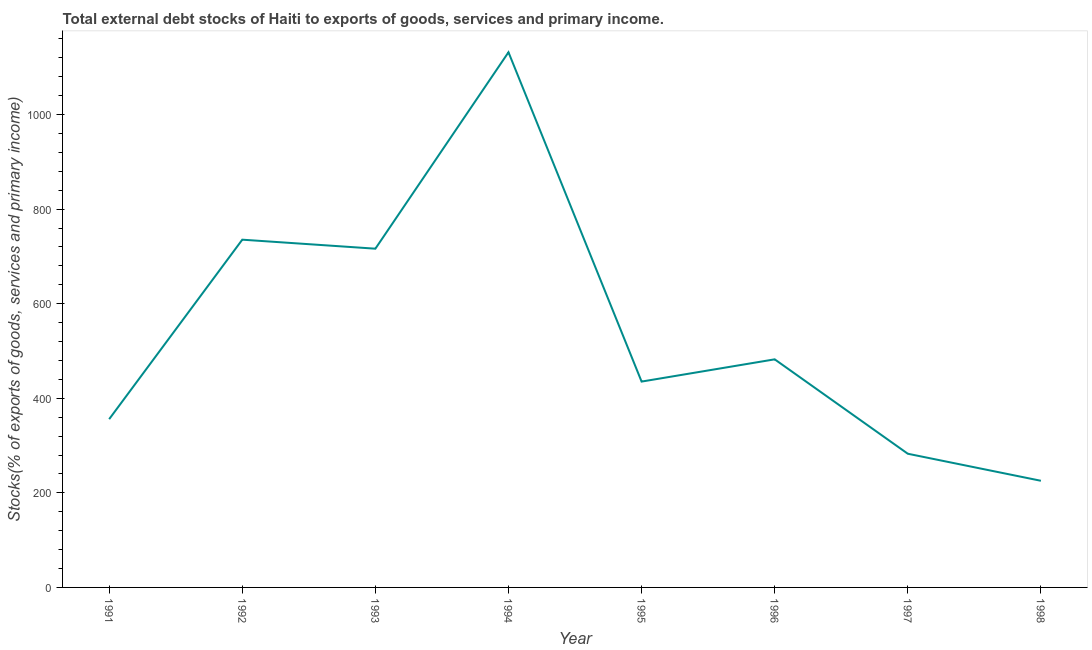What is the external debt stocks in 1995?
Your answer should be compact. 435.33. Across all years, what is the maximum external debt stocks?
Give a very brief answer. 1131.82. Across all years, what is the minimum external debt stocks?
Offer a very short reply. 225.54. In which year was the external debt stocks maximum?
Provide a succinct answer. 1994. What is the sum of the external debt stocks?
Your response must be concise. 4365.47. What is the difference between the external debt stocks in 1995 and 1996?
Ensure brevity in your answer.  -47.05. What is the average external debt stocks per year?
Provide a short and direct response. 545.68. What is the median external debt stocks?
Keep it short and to the point. 458.85. In how many years, is the external debt stocks greater than 360 %?
Provide a short and direct response. 5. Do a majority of the years between 1993 and 1994 (inclusive) have external debt stocks greater than 640 %?
Offer a very short reply. Yes. What is the ratio of the external debt stocks in 1992 to that in 1995?
Your answer should be very brief. 1.69. Is the external debt stocks in 1994 less than that in 1996?
Provide a succinct answer. No. Is the difference between the external debt stocks in 1992 and 1993 greater than the difference between any two years?
Your answer should be compact. No. What is the difference between the highest and the second highest external debt stocks?
Provide a short and direct response. 396.38. Is the sum of the external debt stocks in 1993 and 1995 greater than the maximum external debt stocks across all years?
Your response must be concise. Yes. What is the difference between the highest and the lowest external debt stocks?
Keep it short and to the point. 906.28. How many lines are there?
Keep it short and to the point. 1. How many years are there in the graph?
Your answer should be compact. 8. What is the difference between two consecutive major ticks on the Y-axis?
Give a very brief answer. 200. Are the values on the major ticks of Y-axis written in scientific E-notation?
Provide a short and direct response. No. What is the title of the graph?
Keep it short and to the point. Total external debt stocks of Haiti to exports of goods, services and primary income. What is the label or title of the X-axis?
Provide a short and direct response. Year. What is the label or title of the Y-axis?
Your answer should be very brief. Stocks(% of exports of goods, services and primary income). What is the Stocks(% of exports of goods, services and primary income) of 1991?
Give a very brief answer. 355.87. What is the Stocks(% of exports of goods, services and primary income) of 1992?
Your answer should be compact. 735.43. What is the Stocks(% of exports of goods, services and primary income) in 1993?
Your answer should be compact. 716.38. What is the Stocks(% of exports of goods, services and primary income) in 1994?
Offer a terse response. 1131.82. What is the Stocks(% of exports of goods, services and primary income) of 1995?
Give a very brief answer. 435.33. What is the Stocks(% of exports of goods, services and primary income) in 1996?
Provide a short and direct response. 482.38. What is the Stocks(% of exports of goods, services and primary income) in 1997?
Give a very brief answer. 282.72. What is the Stocks(% of exports of goods, services and primary income) in 1998?
Give a very brief answer. 225.54. What is the difference between the Stocks(% of exports of goods, services and primary income) in 1991 and 1992?
Offer a very short reply. -379.57. What is the difference between the Stocks(% of exports of goods, services and primary income) in 1991 and 1993?
Offer a terse response. -360.51. What is the difference between the Stocks(% of exports of goods, services and primary income) in 1991 and 1994?
Your answer should be compact. -775.95. What is the difference between the Stocks(% of exports of goods, services and primary income) in 1991 and 1995?
Your response must be concise. -79.46. What is the difference between the Stocks(% of exports of goods, services and primary income) in 1991 and 1996?
Make the answer very short. -126.51. What is the difference between the Stocks(% of exports of goods, services and primary income) in 1991 and 1997?
Your response must be concise. 73.15. What is the difference between the Stocks(% of exports of goods, services and primary income) in 1991 and 1998?
Your answer should be compact. 130.33. What is the difference between the Stocks(% of exports of goods, services and primary income) in 1992 and 1993?
Give a very brief answer. 19.05. What is the difference between the Stocks(% of exports of goods, services and primary income) in 1992 and 1994?
Make the answer very short. -396.38. What is the difference between the Stocks(% of exports of goods, services and primary income) in 1992 and 1995?
Offer a very short reply. 300.1. What is the difference between the Stocks(% of exports of goods, services and primary income) in 1992 and 1996?
Your response must be concise. 253.06. What is the difference between the Stocks(% of exports of goods, services and primary income) in 1992 and 1997?
Ensure brevity in your answer.  452.71. What is the difference between the Stocks(% of exports of goods, services and primary income) in 1992 and 1998?
Offer a terse response. 509.9. What is the difference between the Stocks(% of exports of goods, services and primary income) in 1993 and 1994?
Your response must be concise. -415.44. What is the difference between the Stocks(% of exports of goods, services and primary income) in 1993 and 1995?
Make the answer very short. 281.05. What is the difference between the Stocks(% of exports of goods, services and primary income) in 1993 and 1996?
Make the answer very short. 234. What is the difference between the Stocks(% of exports of goods, services and primary income) in 1993 and 1997?
Offer a terse response. 433.66. What is the difference between the Stocks(% of exports of goods, services and primary income) in 1993 and 1998?
Provide a succinct answer. 490.84. What is the difference between the Stocks(% of exports of goods, services and primary income) in 1994 and 1995?
Keep it short and to the point. 696.49. What is the difference between the Stocks(% of exports of goods, services and primary income) in 1994 and 1996?
Make the answer very short. 649.44. What is the difference between the Stocks(% of exports of goods, services and primary income) in 1994 and 1997?
Provide a succinct answer. 849.1. What is the difference between the Stocks(% of exports of goods, services and primary income) in 1994 and 1998?
Your answer should be very brief. 906.28. What is the difference between the Stocks(% of exports of goods, services and primary income) in 1995 and 1996?
Keep it short and to the point. -47.05. What is the difference between the Stocks(% of exports of goods, services and primary income) in 1995 and 1997?
Keep it short and to the point. 152.61. What is the difference between the Stocks(% of exports of goods, services and primary income) in 1995 and 1998?
Your answer should be compact. 209.79. What is the difference between the Stocks(% of exports of goods, services and primary income) in 1996 and 1997?
Your response must be concise. 199.66. What is the difference between the Stocks(% of exports of goods, services and primary income) in 1996 and 1998?
Your answer should be very brief. 256.84. What is the difference between the Stocks(% of exports of goods, services and primary income) in 1997 and 1998?
Make the answer very short. 57.18. What is the ratio of the Stocks(% of exports of goods, services and primary income) in 1991 to that in 1992?
Offer a very short reply. 0.48. What is the ratio of the Stocks(% of exports of goods, services and primary income) in 1991 to that in 1993?
Keep it short and to the point. 0.5. What is the ratio of the Stocks(% of exports of goods, services and primary income) in 1991 to that in 1994?
Provide a succinct answer. 0.31. What is the ratio of the Stocks(% of exports of goods, services and primary income) in 1991 to that in 1995?
Give a very brief answer. 0.82. What is the ratio of the Stocks(% of exports of goods, services and primary income) in 1991 to that in 1996?
Give a very brief answer. 0.74. What is the ratio of the Stocks(% of exports of goods, services and primary income) in 1991 to that in 1997?
Offer a very short reply. 1.26. What is the ratio of the Stocks(% of exports of goods, services and primary income) in 1991 to that in 1998?
Your answer should be very brief. 1.58. What is the ratio of the Stocks(% of exports of goods, services and primary income) in 1992 to that in 1993?
Your response must be concise. 1.03. What is the ratio of the Stocks(% of exports of goods, services and primary income) in 1992 to that in 1994?
Provide a succinct answer. 0.65. What is the ratio of the Stocks(% of exports of goods, services and primary income) in 1992 to that in 1995?
Give a very brief answer. 1.69. What is the ratio of the Stocks(% of exports of goods, services and primary income) in 1992 to that in 1996?
Offer a terse response. 1.52. What is the ratio of the Stocks(% of exports of goods, services and primary income) in 1992 to that in 1997?
Offer a terse response. 2.6. What is the ratio of the Stocks(% of exports of goods, services and primary income) in 1992 to that in 1998?
Your answer should be compact. 3.26. What is the ratio of the Stocks(% of exports of goods, services and primary income) in 1993 to that in 1994?
Provide a short and direct response. 0.63. What is the ratio of the Stocks(% of exports of goods, services and primary income) in 1993 to that in 1995?
Provide a succinct answer. 1.65. What is the ratio of the Stocks(% of exports of goods, services and primary income) in 1993 to that in 1996?
Make the answer very short. 1.49. What is the ratio of the Stocks(% of exports of goods, services and primary income) in 1993 to that in 1997?
Give a very brief answer. 2.53. What is the ratio of the Stocks(% of exports of goods, services and primary income) in 1993 to that in 1998?
Offer a very short reply. 3.18. What is the ratio of the Stocks(% of exports of goods, services and primary income) in 1994 to that in 1996?
Ensure brevity in your answer.  2.35. What is the ratio of the Stocks(% of exports of goods, services and primary income) in 1994 to that in 1997?
Offer a very short reply. 4. What is the ratio of the Stocks(% of exports of goods, services and primary income) in 1994 to that in 1998?
Make the answer very short. 5.02. What is the ratio of the Stocks(% of exports of goods, services and primary income) in 1995 to that in 1996?
Give a very brief answer. 0.9. What is the ratio of the Stocks(% of exports of goods, services and primary income) in 1995 to that in 1997?
Your answer should be compact. 1.54. What is the ratio of the Stocks(% of exports of goods, services and primary income) in 1995 to that in 1998?
Make the answer very short. 1.93. What is the ratio of the Stocks(% of exports of goods, services and primary income) in 1996 to that in 1997?
Give a very brief answer. 1.71. What is the ratio of the Stocks(% of exports of goods, services and primary income) in 1996 to that in 1998?
Offer a terse response. 2.14. What is the ratio of the Stocks(% of exports of goods, services and primary income) in 1997 to that in 1998?
Your answer should be compact. 1.25. 